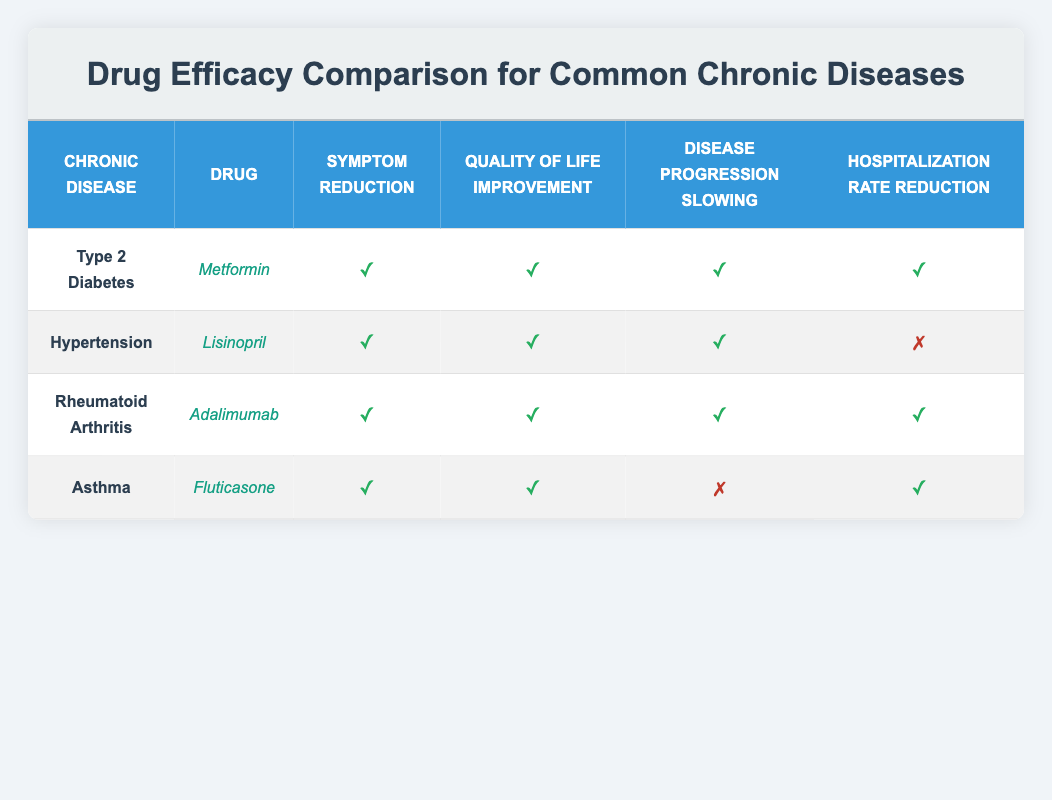What drug is effective at reducing symptoms in Type 2 Diabetes? According to the table, Metformin is listed under Type 2 Diabetes, and it has a checkmark for Symptom Reduction, indicating it is effective in this area.
Answer: Metformin Does Lisinopril reduce hospitalization rates for Hypertension? The table indicates that while Lisinopril has checkmarks for Symptom Reduction, Quality of Life Improvement, and Disease Progression Slowing, it has a cross for Hospitalization Rate Reduction, showing it does not effectively reduce hospitalization rates.
Answer: No Which drug demonstrates the highest efficacy across all metrics? By examining the rows, Adalimumab for Rheumatoid Arthritis has checkmarks in all four efficacy metrics: Symptom Reduction, Quality of Life Improvement, Disease Progression Slowing, and Hospitalization Rate Reduction, indicating it has the highest efficacy.
Answer: Adalimumab For which disease does Fluticasone not slow disease progression? The table shows that for Asthma, Fluticasone has a cross for Disease Progression Slowing. This indicates that Fluticasone does not effectively slow disease progression in this case.
Answer: Asthma What proportion of drugs results in hospitalization rate reduction among the listed treatments? There are four drugs listed: Metformin, Lisinopril, Adalimumab, and Fluticasone. Out of these, three (Metformin, Adalimumab, and Fluticasone) result in hospitalization rate reduction, giving a proportion of 3 out of 4, which simplifies to 75%.
Answer: 75% Which drug is the only one that does not improve hospitalization rates but improves other metrics for Hypertension? In the case of Lisinopril for Hypertension, the table shows that while it does improve Symptom Reduction, Quality of Life Improvement, and Disease Progression Slowing, it does not lead to a reduction in hospitalization rates. Thus, Lisinopril fits this description perfectly.
Answer: Lisinopril What are the efficacy outcomes for Adalimumab? Looking at the entry for Adalimumab under Rheumatoid Arthritis, all efficacy outcomes have checkmarks: it reduces symptoms, improves quality of life, slows disease progression, and reduces hospitalization rates. This means that Adalimumab is effective in all four aspects.
Answer: All are effective Which chronic disease has a drug that improves the quality of life but does not slow disease progression? The table indicates that Fluticasone for Asthma improves Quality of Life but has a cross for Disease Progression Slowing. Therefore, asthma is the chronic disease in this context.
Answer: Asthma 